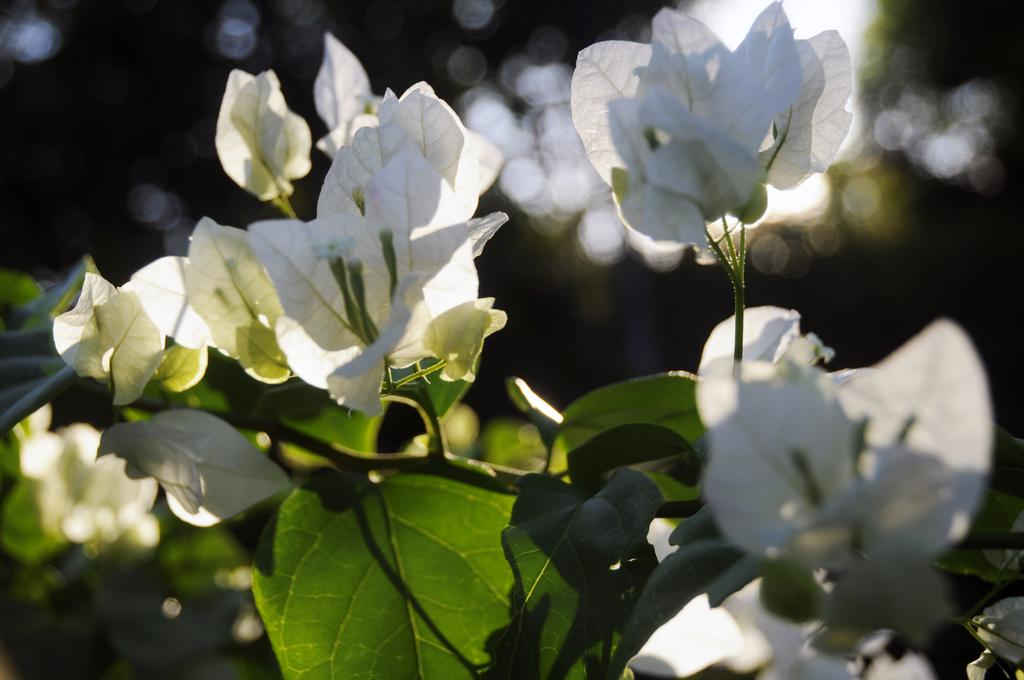What is present in the image? There is a tree in the image. Can you describe the tree's appearance? The tree has white and green leaves. How many nails are attached to the tree in the image? There are no nails present in the image; it only features a tree with white and green leaves. 